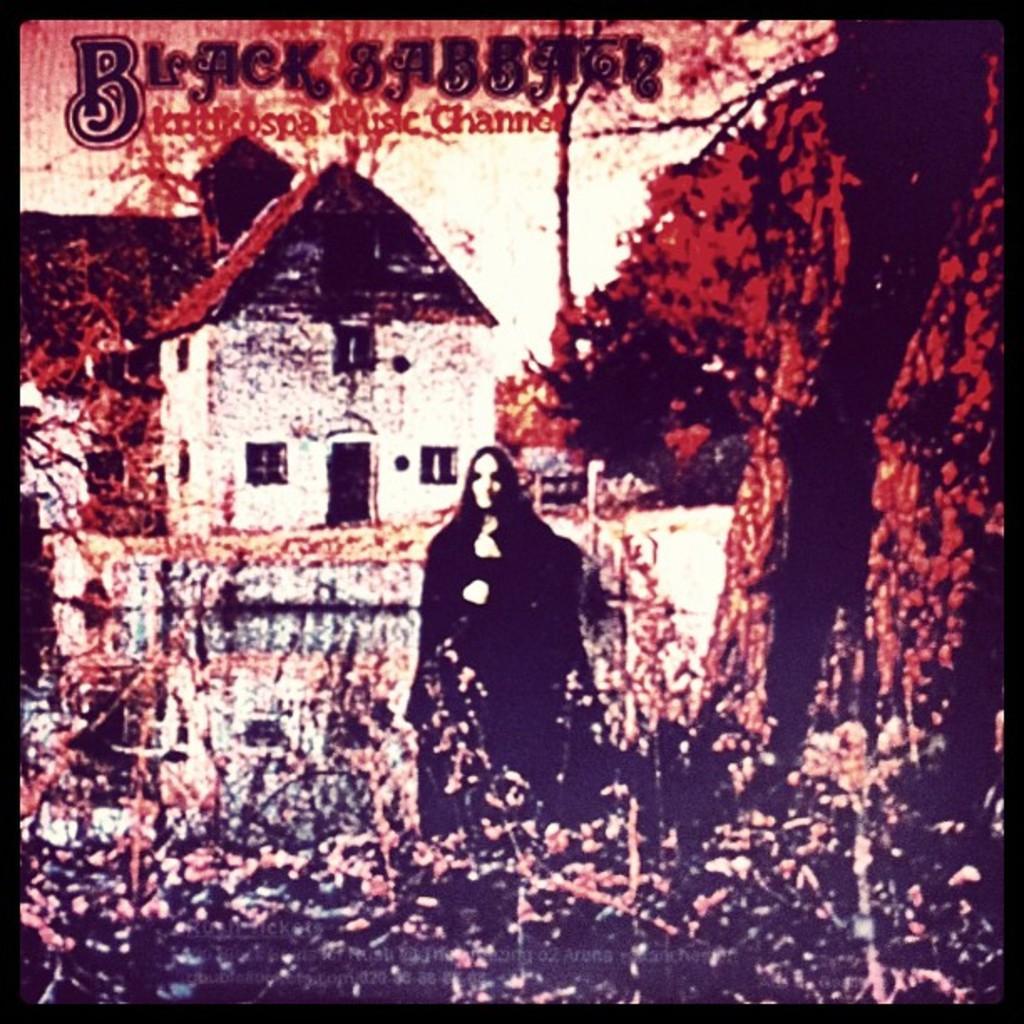How would you summarize this image in a sentence or two? This is an edited image. In this image we can see building, trees, woman standing on the ground and some text at the top of the image. 